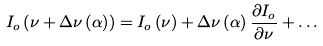Convert formula to latex. <formula><loc_0><loc_0><loc_500><loc_500>I _ { o } \left ( \nu + \Delta \nu \left ( \alpha \right ) \right ) = I _ { o } \left ( \nu \right ) + \Delta \nu \left ( \alpha \right ) \frac { \partial I _ { o } } { \partial \nu } + \dots</formula> 